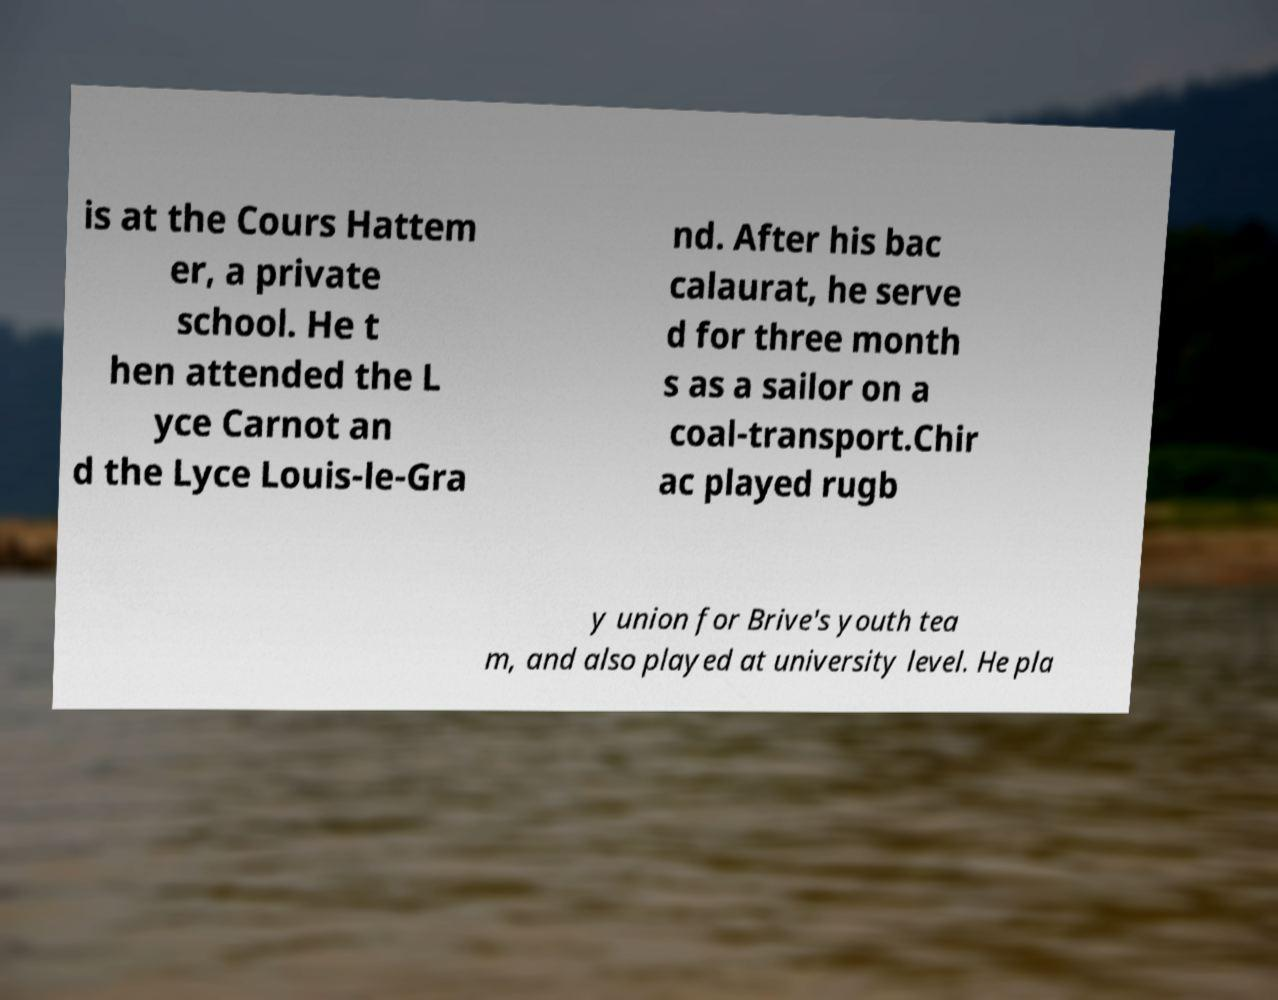Can you read and provide the text displayed in the image?This photo seems to have some interesting text. Can you extract and type it out for me? is at the Cours Hattem er, a private school. He t hen attended the L yce Carnot an d the Lyce Louis-le-Gra nd. After his bac calaurat, he serve d for three month s as a sailor on a coal-transport.Chir ac played rugb y union for Brive's youth tea m, and also played at university level. He pla 